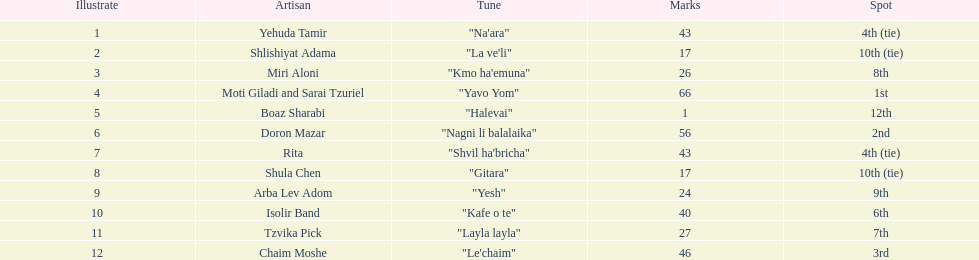What is the total amount of ties in this competition? 2. Would you be able to parse every entry in this table? {'header': ['Illustrate', 'Artisan', 'Tune', 'Marks', 'Spot'], 'rows': [['1', 'Yehuda Tamir', '"Na\'ara"', '43', '4th (tie)'], ['2', 'Shlishiyat Adama', '"La ve\'li"', '17', '10th (tie)'], ['3', 'Miri Aloni', '"Kmo ha\'emuna"', '26', '8th'], ['4', 'Moti Giladi and Sarai Tzuriel', '"Yavo Yom"', '66', '1st'], ['5', 'Boaz Sharabi', '"Halevai"', '1', '12th'], ['6', 'Doron Mazar', '"Nagni li balalaika"', '56', '2nd'], ['7', 'Rita', '"Shvil ha\'bricha"', '43', '4th (tie)'], ['8', 'Shula Chen', '"Gitara"', '17', '10th (tie)'], ['9', 'Arba Lev Adom', '"Yesh"', '24', '9th'], ['10', 'Isolir Band', '"Kafe o te"', '40', '6th'], ['11', 'Tzvika Pick', '"Layla layla"', '27', '7th'], ['12', 'Chaim Moshe', '"Le\'chaim"', '46', '3rd']]} 